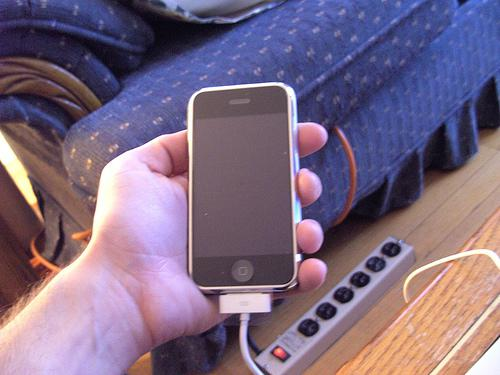Question: what is the main color of the couch in the background?
Choices:
A. White.
B. Black.
C. Brown.
D. Blue.
Answer with the letter. Answer: D Question: how many outlets are on the power strip?
Choices:
A. Six.
B. Four.
C. Five.
D. Three.
Answer with the letter. Answer: A Question: where is the power strip?
Choices:
A. Floor.
B. Under the desk.
C. On the shelf.
D. Behind the computer.
Answer with the letter. Answer: A Question: what hand is holding the phone?
Choices:
A. Right.
B. Both hands.
C. Left.
D. None.
Answer with the letter. Answer: C 